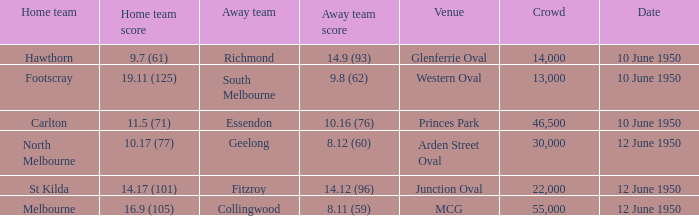What was the size of the audience when the vfl took place at mcg? 55000.0. 